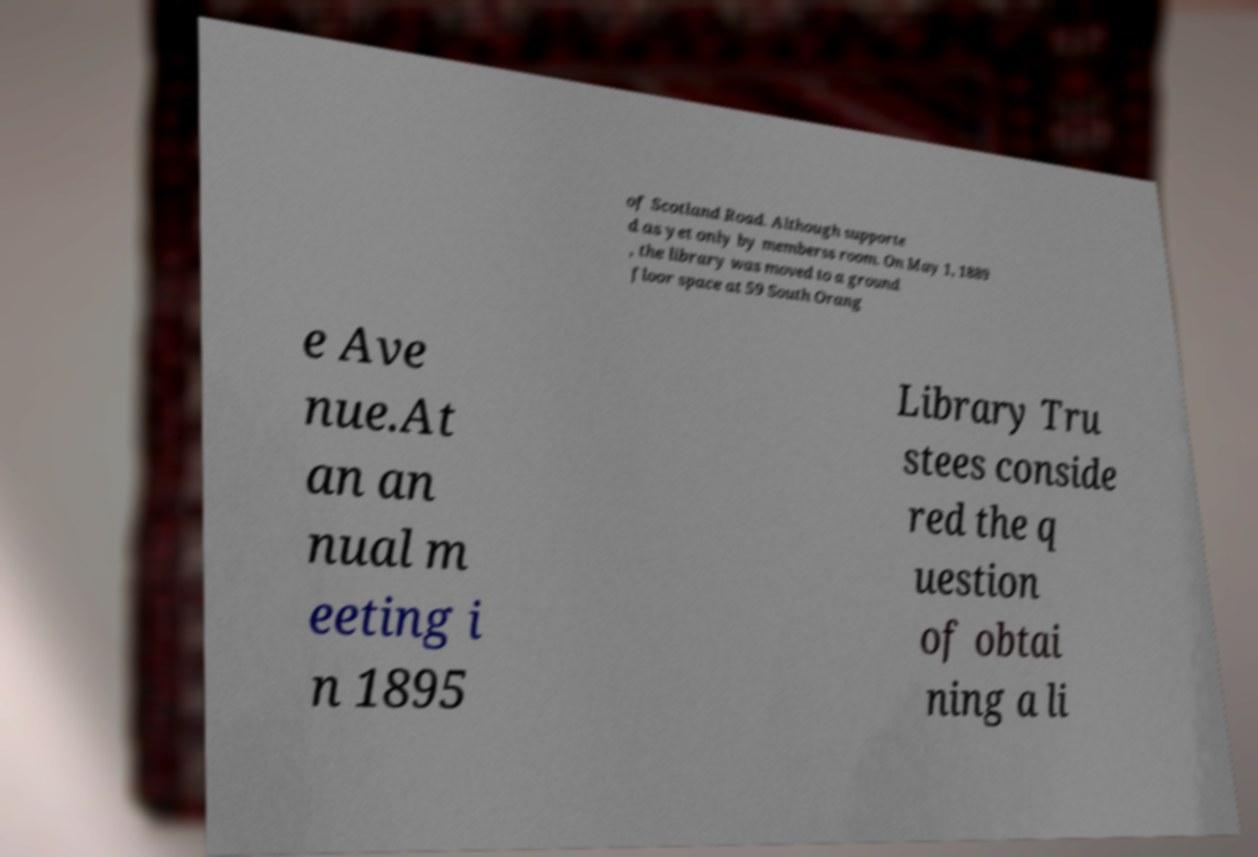What messages or text are displayed in this image? I need them in a readable, typed format. of Scotland Road. Although supporte d as yet only by memberss room. On May 1, 1889 , the library was moved to a ground floor space at 59 South Orang e Ave nue.At an an nual m eeting i n 1895 Library Tru stees conside red the q uestion of obtai ning a li 